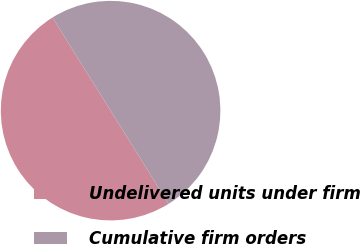Convert chart. <chart><loc_0><loc_0><loc_500><loc_500><pie_chart><fcel>Undelivered units under firm<fcel>Cumulative firm orders<nl><fcel>49.99%<fcel>50.01%<nl></chart> 